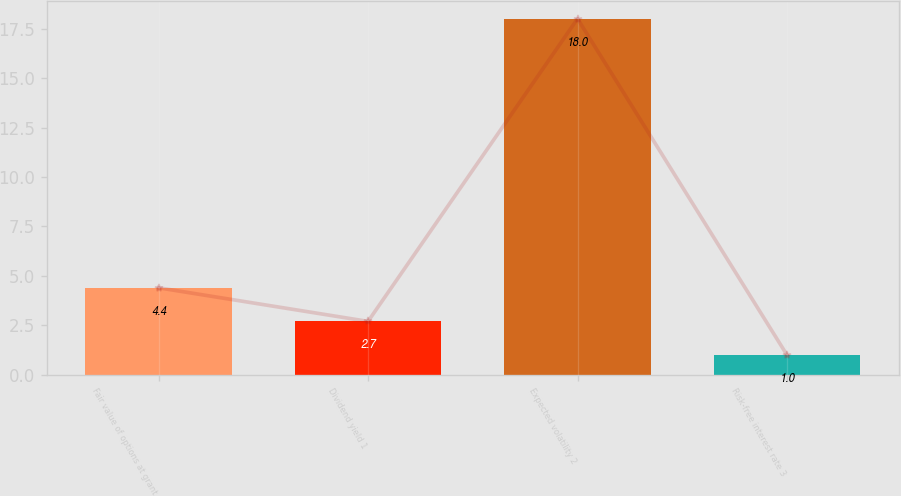<chart> <loc_0><loc_0><loc_500><loc_500><bar_chart><fcel>Fair value of options at grant<fcel>Dividend yield 1<fcel>Expected volatility 2<fcel>Risk-free interest rate 3<nl><fcel>4.4<fcel>2.7<fcel>18<fcel>1<nl></chart> 